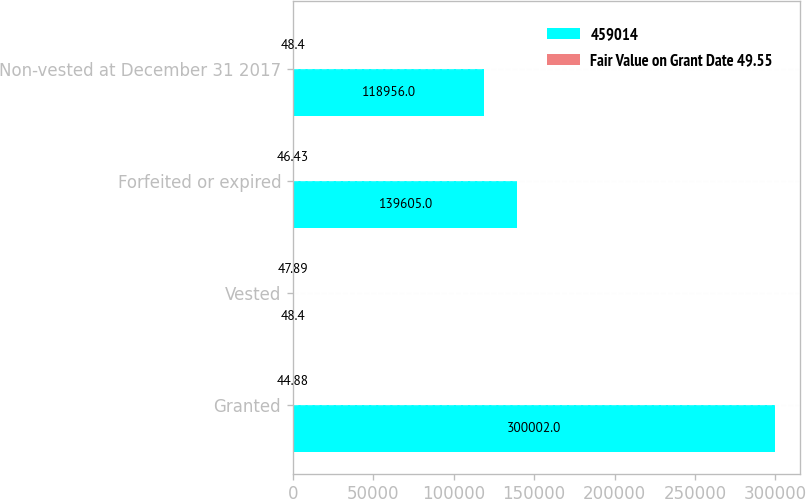Convert chart to OTSL. <chart><loc_0><loc_0><loc_500><loc_500><stacked_bar_chart><ecel><fcel>Granted<fcel>Vested<fcel>Forfeited or expired<fcel>Non-vested at December 31 2017<nl><fcel>459014<fcel>300002<fcel>48.4<fcel>139605<fcel>118956<nl><fcel>Fair Value on Grant Date 49.55<fcel>44.88<fcel>47.89<fcel>46.43<fcel>48.4<nl></chart> 